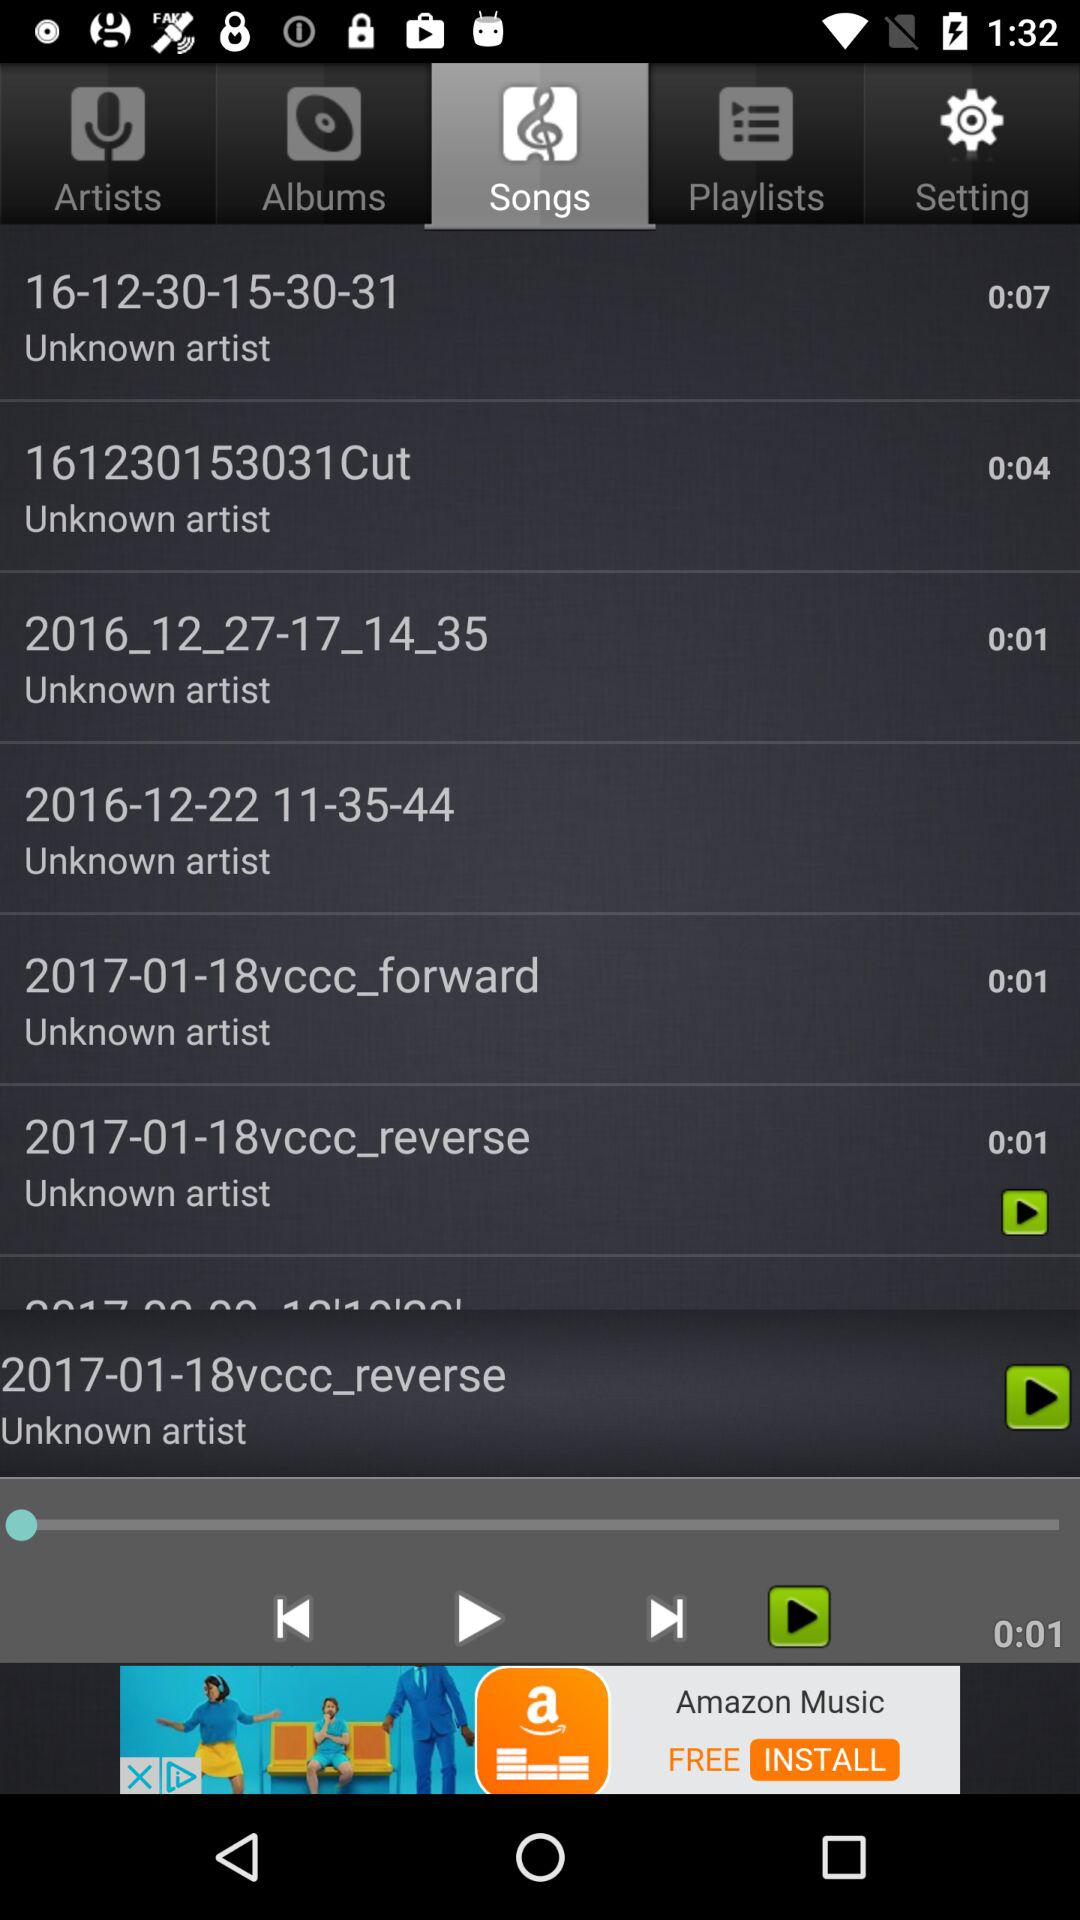What is the time duration of the current song? The time duration of the current song is one second. 